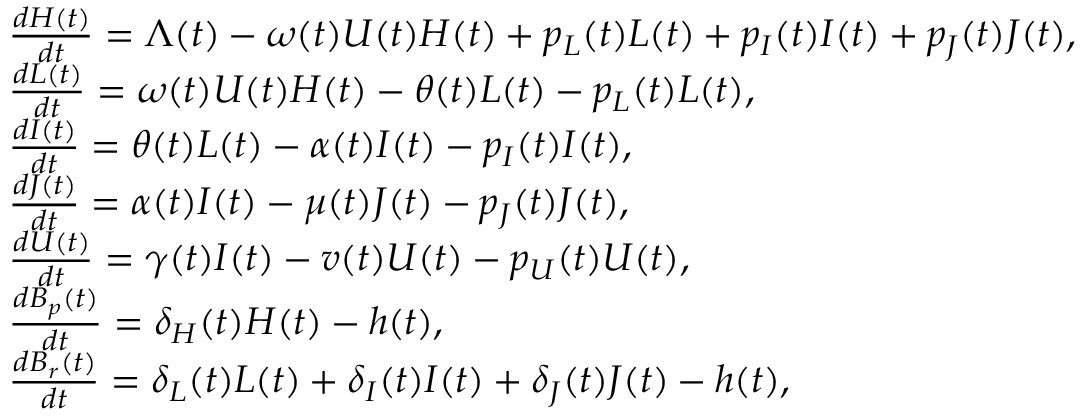Convert formula to latex. <formula><loc_0><loc_0><loc_500><loc_500>\begin{array} { l } { \frac { d H ( t ) } { d t } = \Lambda ( t ) - \omega ( t ) U ( t ) H ( t ) + p _ { L } ( t ) L ( t ) + p _ { I } ( t ) I ( t ) + p _ { J } ( t ) J ( t ) , } \\ { \frac { d L ( t ) } { d t } = \omega ( t ) U ( t ) H ( t ) - \theta ( t ) L ( t ) - p _ { L } ( t ) L ( t ) , } \\ { \frac { d I ( t ) } { d t } = \theta ( t ) L ( t ) - \alpha ( t ) I ( t ) - p _ { I } ( t ) I ( t ) , } \\ { \frac { d J ( t ) } { d t } = \alpha ( t ) I ( t ) - \mu ( t ) J ( t ) - p _ { J } ( t ) J ( t ) , } \\ { \frac { d U ( t ) } { d t } = \gamma ( t ) I ( t ) - v ( t ) U ( t ) - p _ { U } ( t ) U ( t ) , } \\ { \frac { d B _ { p } ( t ) } { d t } = \delta _ { H } ( t ) H ( t ) - h ( t ) , } \\ { \frac { d B _ { r } ( t ) } { d t } = \delta _ { L } ( t ) L ( t ) + \delta _ { I } ( t ) I ( t ) + \delta _ { J } ( t ) J ( t ) - h ( t ) , } \end{array}</formula> 